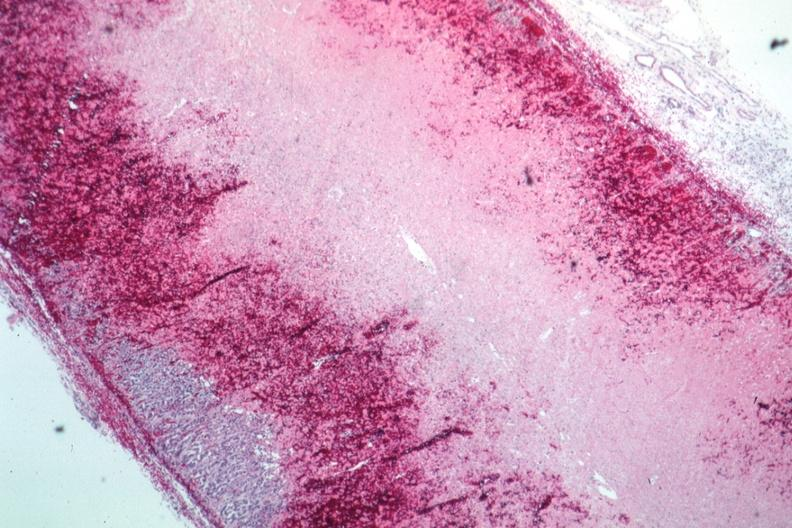s adrenal present?
Answer the question using a single word or phrase. Yes 